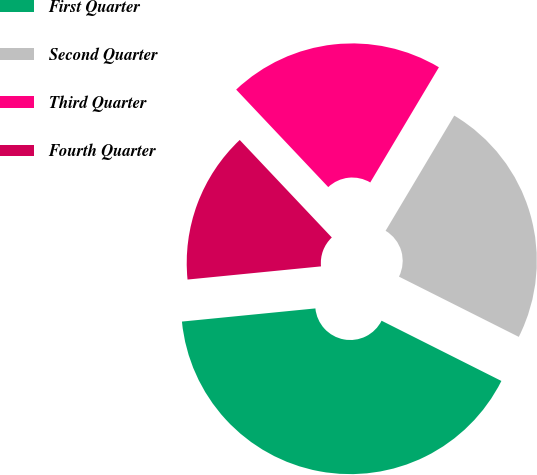<chart> <loc_0><loc_0><loc_500><loc_500><pie_chart><fcel>First Quarter<fcel>Second Quarter<fcel>Third Quarter<fcel>Fourth Quarter<nl><fcel>41.02%<fcel>23.86%<fcel>20.6%<fcel>14.52%<nl></chart> 